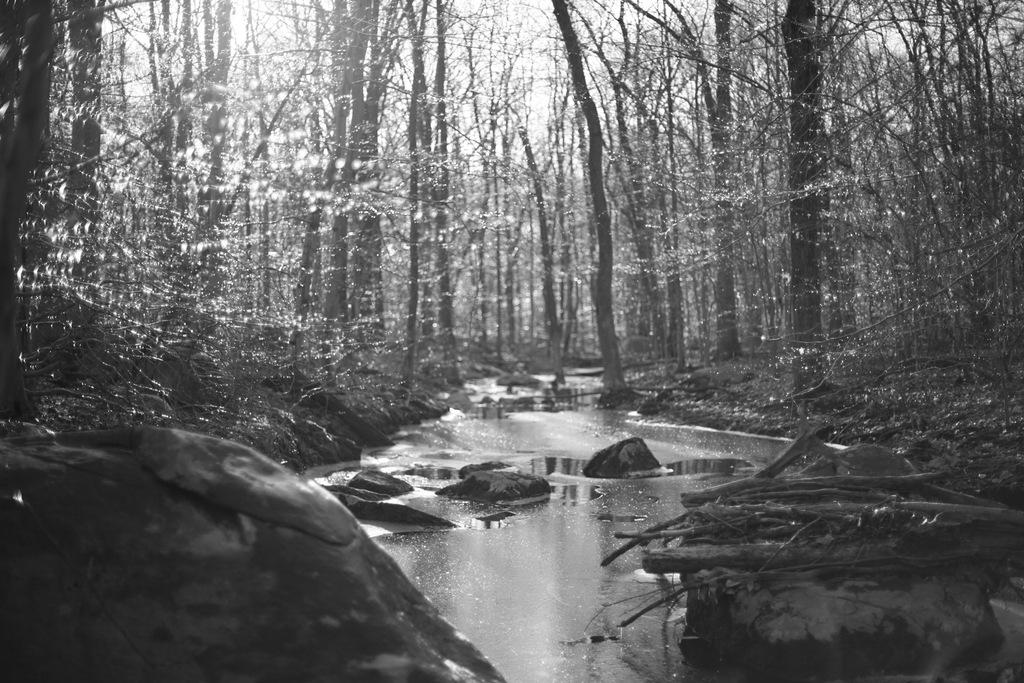What is the color scheme of the image? The image is black and white. What type of natural elements can be seen in the image? There are trees, the sky, water, rocks, and branches visible in the image. How many oranges are hanging from the branches in the image? There are no oranges present in the image; it features trees with branches. Can you tell me if the trees in the image are sleeping? Trees do not sleep, so this question is not applicable to the image. 